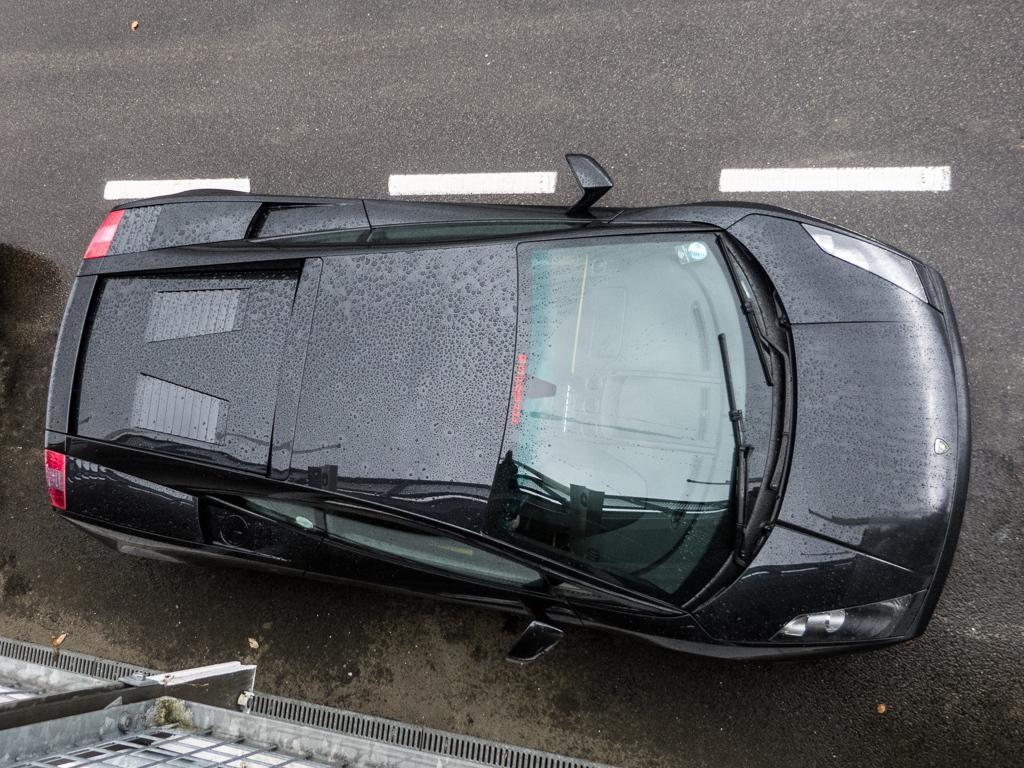Can you describe this image briefly? In this image we can see the top view of the black color car kept on the roads on which we can see the dew. Here we can see the wall of a building. 